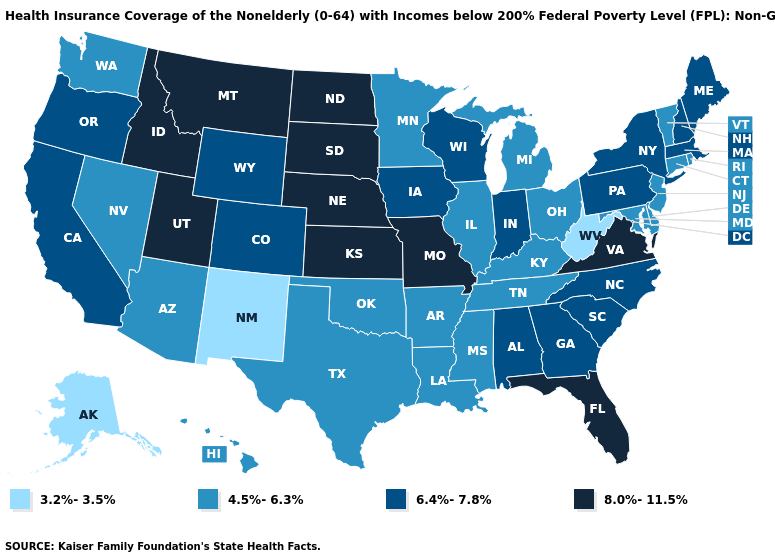Name the states that have a value in the range 4.5%-6.3%?
Quick response, please. Arizona, Arkansas, Connecticut, Delaware, Hawaii, Illinois, Kentucky, Louisiana, Maryland, Michigan, Minnesota, Mississippi, Nevada, New Jersey, Ohio, Oklahoma, Rhode Island, Tennessee, Texas, Vermont, Washington. What is the value of Nebraska?
Concise answer only. 8.0%-11.5%. Which states have the lowest value in the USA?
Write a very short answer. Alaska, New Mexico, West Virginia. Among the states that border Maryland , which have the highest value?
Be succinct. Virginia. What is the value of Rhode Island?
Be succinct. 4.5%-6.3%. Name the states that have a value in the range 3.2%-3.5%?
Be succinct. Alaska, New Mexico, West Virginia. What is the value of Alabama?
Quick response, please. 6.4%-7.8%. Which states have the lowest value in the USA?
Write a very short answer. Alaska, New Mexico, West Virginia. What is the highest value in the USA?
Quick response, please. 8.0%-11.5%. What is the highest value in the MidWest ?
Concise answer only. 8.0%-11.5%. Among the states that border New Jersey , which have the highest value?
Concise answer only. New York, Pennsylvania. Name the states that have a value in the range 8.0%-11.5%?
Concise answer only. Florida, Idaho, Kansas, Missouri, Montana, Nebraska, North Dakota, South Dakota, Utah, Virginia. Does Wyoming have the highest value in the USA?
Short answer required. No. Among the states that border South Dakota , which have the lowest value?
Concise answer only. Minnesota. Does West Virginia have the lowest value in the USA?
Short answer required. Yes. 